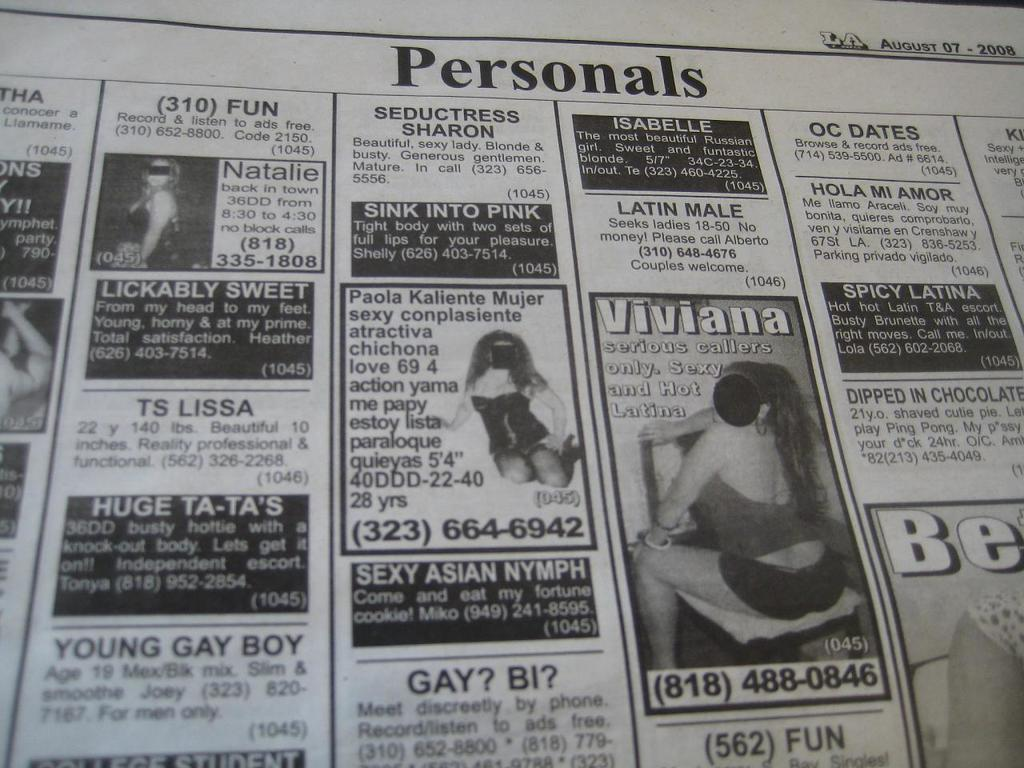What is the main object in the image? There is a newspaper in the image. What can be found on the newspaper? The newspaper has printed text and pictures of some persons. What is the name of the tramp featured in the newspaper? There is no tramp mentioned or featured in the image, as the facts only mention pictures of some persons. 